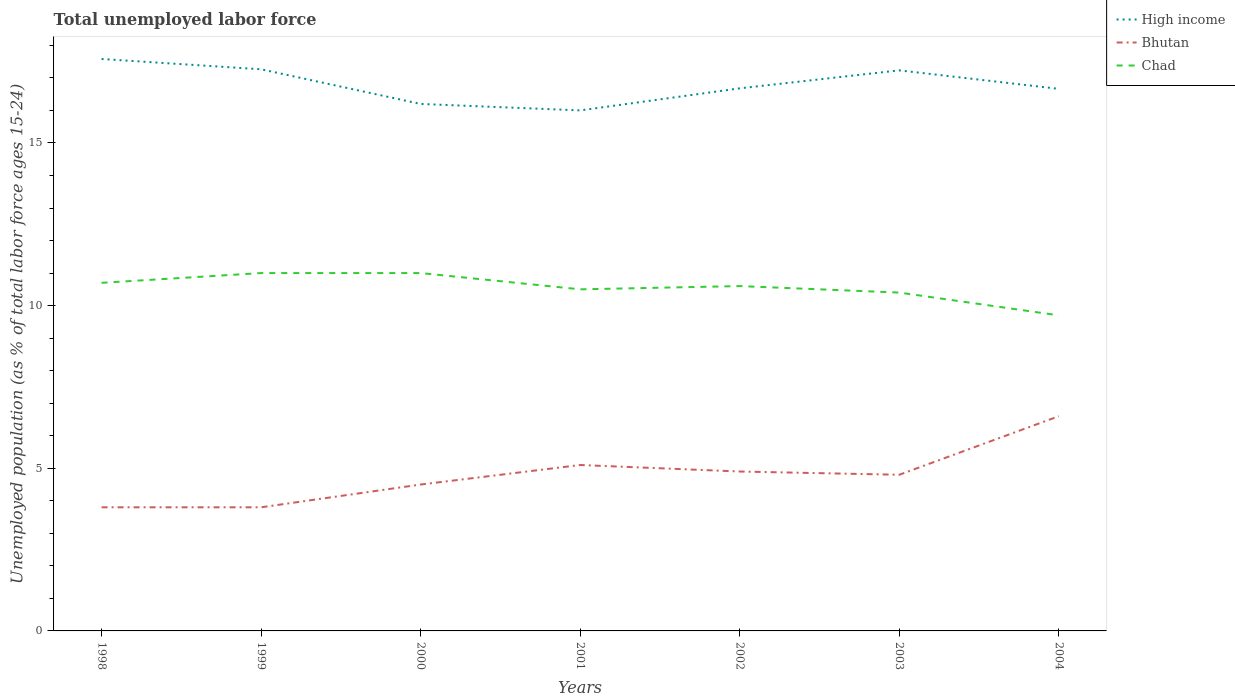Is the number of lines equal to the number of legend labels?
Give a very brief answer. Yes. Across all years, what is the maximum percentage of unemployed population in in High income?
Give a very brief answer. 16. What is the total percentage of unemployed population in in Chad in the graph?
Keep it short and to the point. 1.3. What is the difference between the highest and the second highest percentage of unemployed population in in Bhutan?
Provide a succinct answer. 2.8. What is the difference between the highest and the lowest percentage of unemployed population in in Chad?
Give a very brief answer. 4. Is the percentage of unemployed population in in High income strictly greater than the percentage of unemployed population in in Chad over the years?
Offer a very short reply. No. Where does the legend appear in the graph?
Provide a short and direct response. Top right. How are the legend labels stacked?
Offer a terse response. Vertical. What is the title of the graph?
Offer a terse response. Total unemployed labor force. What is the label or title of the Y-axis?
Make the answer very short. Unemployed population (as % of total labor force ages 15-24). What is the Unemployed population (as % of total labor force ages 15-24) of High income in 1998?
Offer a very short reply. 17.58. What is the Unemployed population (as % of total labor force ages 15-24) of Bhutan in 1998?
Give a very brief answer. 3.8. What is the Unemployed population (as % of total labor force ages 15-24) in Chad in 1998?
Provide a succinct answer. 10.7. What is the Unemployed population (as % of total labor force ages 15-24) of High income in 1999?
Give a very brief answer. 17.26. What is the Unemployed population (as % of total labor force ages 15-24) of Bhutan in 1999?
Make the answer very short. 3.8. What is the Unemployed population (as % of total labor force ages 15-24) in Chad in 1999?
Offer a very short reply. 11. What is the Unemployed population (as % of total labor force ages 15-24) in High income in 2000?
Your response must be concise. 16.2. What is the Unemployed population (as % of total labor force ages 15-24) of Chad in 2000?
Your answer should be very brief. 11. What is the Unemployed population (as % of total labor force ages 15-24) of High income in 2001?
Offer a very short reply. 16. What is the Unemployed population (as % of total labor force ages 15-24) of Bhutan in 2001?
Make the answer very short. 5.1. What is the Unemployed population (as % of total labor force ages 15-24) of Chad in 2001?
Your answer should be compact. 10.5. What is the Unemployed population (as % of total labor force ages 15-24) of High income in 2002?
Give a very brief answer. 16.68. What is the Unemployed population (as % of total labor force ages 15-24) of Bhutan in 2002?
Make the answer very short. 4.9. What is the Unemployed population (as % of total labor force ages 15-24) of Chad in 2002?
Your response must be concise. 10.6. What is the Unemployed population (as % of total labor force ages 15-24) in High income in 2003?
Ensure brevity in your answer.  17.23. What is the Unemployed population (as % of total labor force ages 15-24) of Bhutan in 2003?
Your answer should be compact. 4.8. What is the Unemployed population (as % of total labor force ages 15-24) of Chad in 2003?
Provide a succinct answer. 10.4. What is the Unemployed population (as % of total labor force ages 15-24) in High income in 2004?
Give a very brief answer. 16.66. What is the Unemployed population (as % of total labor force ages 15-24) in Bhutan in 2004?
Your answer should be very brief. 6.6. What is the Unemployed population (as % of total labor force ages 15-24) in Chad in 2004?
Offer a terse response. 9.7. Across all years, what is the maximum Unemployed population (as % of total labor force ages 15-24) of High income?
Your response must be concise. 17.58. Across all years, what is the maximum Unemployed population (as % of total labor force ages 15-24) in Bhutan?
Ensure brevity in your answer.  6.6. Across all years, what is the minimum Unemployed population (as % of total labor force ages 15-24) in High income?
Ensure brevity in your answer.  16. Across all years, what is the minimum Unemployed population (as % of total labor force ages 15-24) of Bhutan?
Offer a very short reply. 3.8. Across all years, what is the minimum Unemployed population (as % of total labor force ages 15-24) in Chad?
Keep it short and to the point. 9.7. What is the total Unemployed population (as % of total labor force ages 15-24) of High income in the graph?
Keep it short and to the point. 117.61. What is the total Unemployed population (as % of total labor force ages 15-24) of Bhutan in the graph?
Offer a terse response. 33.5. What is the total Unemployed population (as % of total labor force ages 15-24) in Chad in the graph?
Offer a very short reply. 73.9. What is the difference between the Unemployed population (as % of total labor force ages 15-24) of High income in 1998 and that in 1999?
Give a very brief answer. 0.32. What is the difference between the Unemployed population (as % of total labor force ages 15-24) in Bhutan in 1998 and that in 1999?
Your answer should be compact. 0. What is the difference between the Unemployed population (as % of total labor force ages 15-24) in High income in 1998 and that in 2000?
Give a very brief answer. 1.38. What is the difference between the Unemployed population (as % of total labor force ages 15-24) in Bhutan in 1998 and that in 2000?
Your answer should be very brief. -0.7. What is the difference between the Unemployed population (as % of total labor force ages 15-24) of High income in 1998 and that in 2001?
Offer a terse response. 1.58. What is the difference between the Unemployed population (as % of total labor force ages 15-24) in Chad in 1998 and that in 2001?
Provide a short and direct response. 0.2. What is the difference between the Unemployed population (as % of total labor force ages 15-24) in High income in 1998 and that in 2002?
Your answer should be compact. 0.9. What is the difference between the Unemployed population (as % of total labor force ages 15-24) of High income in 1998 and that in 2003?
Your answer should be compact. 0.35. What is the difference between the Unemployed population (as % of total labor force ages 15-24) in Bhutan in 1998 and that in 2003?
Offer a terse response. -1. What is the difference between the Unemployed population (as % of total labor force ages 15-24) in Chad in 1998 and that in 2003?
Offer a very short reply. 0.3. What is the difference between the Unemployed population (as % of total labor force ages 15-24) of High income in 1998 and that in 2004?
Offer a terse response. 0.92. What is the difference between the Unemployed population (as % of total labor force ages 15-24) in Bhutan in 1998 and that in 2004?
Offer a terse response. -2.8. What is the difference between the Unemployed population (as % of total labor force ages 15-24) of High income in 1999 and that in 2000?
Your response must be concise. 1.06. What is the difference between the Unemployed population (as % of total labor force ages 15-24) in Bhutan in 1999 and that in 2000?
Your answer should be compact. -0.7. What is the difference between the Unemployed population (as % of total labor force ages 15-24) in High income in 1999 and that in 2001?
Your answer should be compact. 1.26. What is the difference between the Unemployed population (as % of total labor force ages 15-24) of High income in 1999 and that in 2002?
Your response must be concise. 0.59. What is the difference between the Unemployed population (as % of total labor force ages 15-24) of High income in 1999 and that in 2003?
Make the answer very short. 0.03. What is the difference between the Unemployed population (as % of total labor force ages 15-24) of Bhutan in 1999 and that in 2003?
Offer a very short reply. -1. What is the difference between the Unemployed population (as % of total labor force ages 15-24) in High income in 1999 and that in 2004?
Keep it short and to the point. 0.6. What is the difference between the Unemployed population (as % of total labor force ages 15-24) in High income in 2000 and that in 2001?
Your answer should be compact. 0.2. What is the difference between the Unemployed population (as % of total labor force ages 15-24) of Chad in 2000 and that in 2001?
Your answer should be very brief. 0.5. What is the difference between the Unemployed population (as % of total labor force ages 15-24) of High income in 2000 and that in 2002?
Provide a short and direct response. -0.48. What is the difference between the Unemployed population (as % of total labor force ages 15-24) in Bhutan in 2000 and that in 2002?
Offer a very short reply. -0.4. What is the difference between the Unemployed population (as % of total labor force ages 15-24) in High income in 2000 and that in 2003?
Your answer should be very brief. -1.03. What is the difference between the Unemployed population (as % of total labor force ages 15-24) of High income in 2000 and that in 2004?
Your answer should be compact. -0.46. What is the difference between the Unemployed population (as % of total labor force ages 15-24) in Bhutan in 2000 and that in 2004?
Keep it short and to the point. -2.1. What is the difference between the Unemployed population (as % of total labor force ages 15-24) in High income in 2001 and that in 2002?
Offer a very short reply. -0.68. What is the difference between the Unemployed population (as % of total labor force ages 15-24) of Bhutan in 2001 and that in 2002?
Make the answer very short. 0.2. What is the difference between the Unemployed population (as % of total labor force ages 15-24) in High income in 2001 and that in 2003?
Your response must be concise. -1.23. What is the difference between the Unemployed population (as % of total labor force ages 15-24) in Bhutan in 2001 and that in 2003?
Make the answer very short. 0.3. What is the difference between the Unemployed population (as % of total labor force ages 15-24) of High income in 2001 and that in 2004?
Offer a terse response. -0.66. What is the difference between the Unemployed population (as % of total labor force ages 15-24) in Bhutan in 2001 and that in 2004?
Give a very brief answer. -1.5. What is the difference between the Unemployed population (as % of total labor force ages 15-24) in Chad in 2001 and that in 2004?
Your response must be concise. 0.8. What is the difference between the Unemployed population (as % of total labor force ages 15-24) in High income in 2002 and that in 2003?
Your answer should be compact. -0.55. What is the difference between the Unemployed population (as % of total labor force ages 15-24) in Chad in 2002 and that in 2003?
Offer a very short reply. 0.2. What is the difference between the Unemployed population (as % of total labor force ages 15-24) of High income in 2002 and that in 2004?
Provide a short and direct response. 0.02. What is the difference between the Unemployed population (as % of total labor force ages 15-24) of High income in 2003 and that in 2004?
Keep it short and to the point. 0.57. What is the difference between the Unemployed population (as % of total labor force ages 15-24) of Bhutan in 2003 and that in 2004?
Your answer should be very brief. -1.8. What is the difference between the Unemployed population (as % of total labor force ages 15-24) of High income in 1998 and the Unemployed population (as % of total labor force ages 15-24) of Bhutan in 1999?
Keep it short and to the point. 13.78. What is the difference between the Unemployed population (as % of total labor force ages 15-24) in High income in 1998 and the Unemployed population (as % of total labor force ages 15-24) in Chad in 1999?
Make the answer very short. 6.58. What is the difference between the Unemployed population (as % of total labor force ages 15-24) of Bhutan in 1998 and the Unemployed population (as % of total labor force ages 15-24) of Chad in 1999?
Keep it short and to the point. -7.2. What is the difference between the Unemployed population (as % of total labor force ages 15-24) of High income in 1998 and the Unemployed population (as % of total labor force ages 15-24) of Bhutan in 2000?
Keep it short and to the point. 13.08. What is the difference between the Unemployed population (as % of total labor force ages 15-24) of High income in 1998 and the Unemployed population (as % of total labor force ages 15-24) of Chad in 2000?
Ensure brevity in your answer.  6.58. What is the difference between the Unemployed population (as % of total labor force ages 15-24) of Bhutan in 1998 and the Unemployed population (as % of total labor force ages 15-24) of Chad in 2000?
Your answer should be compact. -7.2. What is the difference between the Unemployed population (as % of total labor force ages 15-24) of High income in 1998 and the Unemployed population (as % of total labor force ages 15-24) of Bhutan in 2001?
Make the answer very short. 12.48. What is the difference between the Unemployed population (as % of total labor force ages 15-24) of High income in 1998 and the Unemployed population (as % of total labor force ages 15-24) of Chad in 2001?
Your response must be concise. 7.08. What is the difference between the Unemployed population (as % of total labor force ages 15-24) of High income in 1998 and the Unemployed population (as % of total labor force ages 15-24) of Bhutan in 2002?
Your response must be concise. 12.68. What is the difference between the Unemployed population (as % of total labor force ages 15-24) in High income in 1998 and the Unemployed population (as % of total labor force ages 15-24) in Chad in 2002?
Offer a very short reply. 6.98. What is the difference between the Unemployed population (as % of total labor force ages 15-24) of High income in 1998 and the Unemployed population (as % of total labor force ages 15-24) of Bhutan in 2003?
Give a very brief answer. 12.78. What is the difference between the Unemployed population (as % of total labor force ages 15-24) in High income in 1998 and the Unemployed population (as % of total labor force ages 15-24) in Chad in 2003?
Your answer should be very brief. 7.18. What is the difference between the Unemployed population (as % of total labor force ages 15-24) in Bhutan in 1998 and the Unemployed population (as % of total labor force ages 15-24) in Chad in 2003?
Your response must be concise. -6.6. What is the difference between the Unemployed population (as % of total labor force ages 15-24) of High income in 1998 and the Unemployed population (as % of total labor force ages 15-24) of Bhutan in 2004?
Your response must be concise. 10.98. What is the difference between the Unemployed population (as % of total labor force ages 15-24) of High income in 1998 and the Unemployed population (as % of total labor force ages 15-24) of Chad in 2004?
Give a very brief answer. 7.88. What is the difference between the Unemployed population (as % of total labor force ages 15-24) in Bhutan in 1998 and the Unemployed population (as % of total labor force ages 15-24) in Chad in 2004?
Offer a very short reply. -5.9. What is the difference between the Unemployed population (as % of total labor force ages 15-24) in High income in 1999 and the Unemployed population (as % of total labor force ages 15-24) in Bhutan in 2000?
Offer a terse response. 12.76. What is the difference between the Unemployed population (as % of total labor force ages 15-24) in High income in 1999 and the Unemployed population (as % of total labor force ages 15-24) in Chad in 2000?
Ensure brevity in your answer.  6.26. What is the difference between the Unemployed population (as % of total labor force ages 15-24) of Bhutan in 1999 and the Unemployed population (as % of total labor force ages 15-24) of Chad in 2000?
Keep it short and to the point. -7.2. What is the difference between the Unemployed population (as % of total labor force ages 15-24) of High income in 1999 and the Unemployed population (as % of total labor force ages 15-24) of Bhutan in 2001?
Your response must be concise. 12.16. What is the difference between the Unemployed population (as % of total labor force ages 15-24) in High income in 1999 and the Unemployed population (as % of total labor force ages 15-24) in Chad in 2001?
Offer a terse response. 6.76. What is the difference between the Unemployed population (as % of total labor force ages 15-24) in High income in 1999 and the Unemployed population (as % of total labor force ages 15-24) in Bhutan in 2002?
Ensure brevity in your answer.  12.36. What is the difference between the Unemployed population (as % of total labor force ages 15-24) of High income in 1999 and the Unemployed population (as % of total labor force ages 15-24) of Chad in 2002?
Your answer should be very brief. 6.66. What is the difference between the Unemployed population (as % of total labor force ages 15-24) in Bhutan in 1999 and the Unemployed population (as % of total labor force ages 15-24) in Chad in 2002?
Your response must be concise. -6.8. What is the difference between the Unemployed population (as % of total labor force ages 15-24) in High income in 1999 and the Unemployed population (as % of total labor force ages 15-24) in Bhutan in 2003?
Your answer should be compact. 12.46. What is the difference between the Unemployed population (as % of total labor force ages 15-24) of High income in 1999 and the Unemployed population (as % of total labor force ages 15-24) of Chad in 2003?
Make the answer very short. 6.86. What is the difference between the Unemployed population (as % of total labor force ages 15-24) in Bhutan in 1999 and the Unemployed population (as % of total labor force ages 15-24) in Chad in 2003?
Offer a very short reply. -6.6. What is the difference between the Unemployed population (as % of total labor force ages 15-24) in High income in 1999 and the Unemployed population (as % of total labor force ages 15-24) in Bhutan in 2004?
Your answer should be compact. 10.66. What is the difference between the Unemployed population (as % of total labor force ages 15-24) in High income in 1999 and the Unemployed population (as % of total labor force ages 15-24) in Chad in 2004?
Make the answer very short. 7.56. What is the difference between the Unemployed population (as % of total labor force ages 15-24) of Bhutan in 1999 and the Unemployed population (as % of total labor force ages 15-24) of Chad in 2004?
Provide a succinct answer. -5.9. What is the difference between the Unemployed population (as % of total labor force ages 15-24) of High income in 2000 and the Unemployed population (as % of total labor force ages 15-24) of Bhutan in 2001?
Provide a short and direct response. 11.1. What is the difference between the Unemployed population (as % of total labor force ages 15-24) in High income in 2000 and the Unemployed population (as % of total labor force ages 15-24) in Chad in 2001?
Provide a short and direct response. 5.7. What is the difference between the Unemployed population (as % of total labor force ages 15-24) of Bhutan in 2000 and the Unemployed population (as % of total labor force ages 15-24) of Chad in 2001?
Ensure brevity in your answer.  -6. What is the difference between the Unemployed population (as % of total labor force ages 15-24) of High income in 2000 and the Unemployed population (as % of total labor force ages 15-24) of Bhutan in 2002?
Ensure brevity in your answer.  11.3. What is the difference between the Unemployed population (as % of total labor force ages 15-24) in High income in 2000 and the Unemployed population (as % of total labor force ages 15-24) in Chad in 2002?
Offer a very short reply. 5.6. What is the difference between the Unemployed population (as % of total labor force ages 15-24) of Bhutan in 2000 and the Unemployed population (as % of total labor force ages 15-24) of Chad in 2002?
Offer a terse response. -6.1. What is the difference between the Unemployed population (as % of total labor force ages 15-24) of High income in 2000 and the Unemployed population (as % of total labor force ages 15-24) of Bhutan in 2003?
Keep it short and to the point. 11.4. What is the difference between the Unemployed population (as % of total labor force ages 15-24) in High income in 2000 and the Unemployed population (as % of total labor force ages 15-24) in Chad in 2003?
Give a very brief answer. 5.8. What is the difference between the Unemployed population (as % of total labor force ages 15-24) of Bhutan in 2000 and the Unemployed population (as % of total labor force ages 15-24) of Chad in 2003?
Keep it short and to the point. -5.9. What is the difference between the Unemployed population (as % of total labor force ages 15-24) in High income in 2000 and the Unemployed population (as % of total labor force ages 15-24) in Bhutan in 2004?
Your response must be concise. 9.6. What is the difference between the Unemployed population (as % of total labor force ages 15-24) in High income in 2000 and the Unemployed population (as % of total labor force ages 15-24) in Chad in 2004?
Your answer should be compact. 6.5. What is the difference between the Unemployed population (as % of total labor force ages 15-24) in High income in 2001 and the Unemployed population (as % of total labor force ages 15-24) in Bhutan in 2002?
Provide a short and direct response. 11.1. What is the difference between the Unemployed population (as % of total labor force ages 15-24) in High income in 2001 and the Unemployed population (as % of total labor force ages 15-24) in Chad in 2002?
Keep it short and to the point. 5.4. What is the difference between the Unemployed population (as % of total labor force ages 15-24) in Bhutan in 2001 and the Unemployed population (as % of total labor force ages 15-24) in Chad in 2002?
Your answer should be very brief. -5.5. What is the difference between the Unemployed population (as % of total labor force ages 15-24) of High income in 2001 and the Unemployed population (as % of total labor force ages 15-24) of Bhutan in 2003?
Offer a very short reply. 11.2. What is the difference between the Unemployed population (as % of total labor force ages 15-24) of High income in 2001 and the Unemployed population (as % of total labor force ages 15-24) of Chad in 2003?
Your answer should be compact. 5.6. What is the difference between the Unemployed population (as % of total labor force ages 15-24) in Bhutan in 2001 and the Unemployed population (as % of total labor force ages 15-24) in Chad in 2003?
Offer a terse response. -5.3. What is the difference between the Unemployed population (as % of total labor force ages 15-24) of High income in 2001 and the Unemployed population (as % of total labor force ages 15-24) of Bhutan in 2004?
Offer a terse response. 9.4. What is the difference between the Unemployed population (as % of total labor force ages 15-24) in High income in 2001 and the Unemployed population (as % of total labor force ages 15-24) in Chad in 2004?
Your answer should be very brief. 6.3. What is the difference between the Unemployed population (as % of total labor force ages 15-24) in Bhutan in 2001 and the Unemployed population (as % of total labor force ages 15-24) in Chad in 2004?
Provide a short and direct response. -4.6. What is the difference between the Unemployed population (as % of total labor force ages 15-24) of High income in 2002 and the Unemployed population (as % of total labor force ages 15-24) of Bhutan in 2003?
Your response must be concise. 11.88. What is the difference between the Unemployed population (as % of total labor force ages 15-24) of High income in 2002 and the Unemployed population (as % of total labor force ages 15-24) of Chad in 2003?
Make the answer very short. 6.28. What is the difference between the Unemployed population (as % of total labor force ages 15-24) in High income in 2002 and the Unemployed population (as % of total labor force ages 15-24) in Bhutan in 2004?
Give a very brief answer. 10.08. What is the difference between the Unemployed population (as % of total labor force ages 15-24) of High income in 2002 and the Unemployed population (as % of total labor force ages 15-24) of Chad in 2004?
Make the answer very short. 6.98. What is the difference between the Unemployed population (as % of total labor force ages 15-24) of High income in 2003 and the Unemployed population (as % of total labor force ages 15-24) of Bhutan in 2004?
Provide a short and direct response. 10.63. What is the difference between the Unemployed population (as % of total labor force ages 15-24) in High income in 2003 and the Unemployed population (as % of total labor force ages 15-24) in Chad in 2004?
Offer a very short reply. 7.53. What is the difference between the Unemployed population (as % of total labor force ages 15-24) in Bhutan in 2003 and the Unemployed population (as % of total labor force ages 15-24) in Chad in 2004?
Provide a short and direct response. -4.9. What is the average Unemployed population (as % of total labor force ages 15-24) of High income per year?
Provide a short and direct response. 16.8. What is the average Unemployed population (as % of total labor force ages 15-24) in Bhutan per year?
Ensure brevity in your answer.  4.79. What is the average Unemployed population (as % of total labor force ages 15-24) of Chad per year?
Your answer should be compact. 10.56. In the year 1998, what is the difference between the Unemployed population (as % of total labor force ages 15-24) in High income and Unemployed population (as % of total labor force ages 15-24) in Bhutan?
Offer a very short reply. 13.78. In the year 1998, what is the difference between the Unemployed population (as % of total labor force ages 15-24) in High income and Unemployed population (as % of total labor force ages 15-24) in Chad?
Provide a short and direct response. 6.88. In the year 1999, what is the difference between the Unemployed population (as % of total labor force ages 15-24) in High income and Unemployed population (as % of total labor force ages 15-24) in Bhutan?
Offer a very short reply. 13.46. In the year 1999, what is the difference between the Unemployed population (as % of total labor force ages 15-24) in High income and Unemployed population (as % of total labor force ages 15-24) in Chad?
Provide a short and direct response. 6.26. In the year 1999, what is the difference between the Unemployed population (as % of total labor force ages 15-24) in Bhutan and Unemployed population (as % of total labor force ages 15-24) in Chad?
Provide a succinct answer. -7.2. In the year 2000, what is the difference between the Unemployed population (as % of total labor force ages 15-24) of High income and Unemployed population (as % of total labor force ages 15-24) of Bhutan?
Offer a terse response. 11.7. In the year 2000, what is the difference between the Unemployed population (as % of total labor force ages 15-24) in High income and Unemployed population (as % of total labor force ages 15-24) in Chad?
Provide a succinct answer. 5.2. In the year 2001, what is the difference between the Unemployed population (as % of total labor force ages 15-24) in High income and Unemployed population (as % of total labor force ages 15-24) in Bhutan?
Ensure brevity in your answer.  10.9. In the year 2001, what is the difference between the Unemployed population (as % of total labor force ages 15-24) of High income and Unemployed population (as % of total labor force ages 15-24) of Chad?
Offer a terse response. 5.5. In the year 2002, what is the difference between the Unemployed population (as % of total labor force ages 15-24) in High income and Unemployed population (as % of total labor force ages 15-24) in Bhutan?
Make the answer very short. 11.78. In the year 2002, what is the difference between the Unemployed population (as % of total labor force ages 15-24) in High income and Unemployed population (as % of total labor force ages 15-24) in Chad?
Make the answer very short. 6.08. In the year 2003, what is the difference between the Unemployed population (as % of total labor force ages 15-24) of High income and Unemployed population (as % of total labor force ages 15-24) of Bhutan?
Your response must be concise. 12.43. In the year 2003, what is the difference between the Unemployed population (as % of total labor force ages 15-24) of High income and Unemployed population (as % of total labor force ages 15-24) of Chad?
Ensure brevity in your answer.  6.83. In the year 2004, what is the difference between the Unemployed population (as % of total labor force ages 15-24) in High income and Unemployed population (as % of total labor force ages 15-24) in Bhutan?
Your answer should be very brief. 10.06. In the year 2004, what is the difference between the Unemployed population (as % of total labor force ages 15-24) of High income and Unemployed population (as % of total labor force ages 15-24) of Chad?
Make the answer very short. 6.96. In the year 2004, what is the difference between the Unemployed population (as % of total labor force ages 15-24) in Bhutan and Unemployed population (as % of total labor force ages 15-24) in Chad?
Provide a succinct answer. -3.1. What is the ratio of the Unemployed population (as % of total labor force ages 15-24) of High income in 1998 to that in 1999?
Offer a terse response. 1.02. What is the ratio of the Unemployed population (as % of total labor force ages 15-24) in Bhutan in 1998 to that in 1999?
Make the answer very short. 1. What is the ratio of the Unemployed population (as % of total labor force ages 15-24) in Chad in 1998 to that in 1999?
Give a very brief answer. 0.97. What is the ratio of the Unemployed population (as % of total labor force ages 15-24) of High income in 1998 to that in 2000?
Provide a short and direct response. 1.09. What is the ratio of the Unemployed population (as % of total labor force ages 15-24) in Bhutan in 1998 to that in 2000?
Make the answer very short. 0.84. What is the ratio of the Unemployed population (as % of total labor force ages 15-24) of Chad in 1998 to that in 2000?
Keep it short and to the point. 0.97. What is the ratio of the Unemployed population (as % of total labor force ages 15-24) in High income in 1998 to that in 2001?
Provide a succinct answer. 1.1. What is the ratio of the Unemployed population (as % of total labor force ages 15-24) in Bhutan in 1998 to that in 2001?
Offer a terse response. 0.75. What is the ratio of the Unemployed population (as % of total labor force ages 15-24) in High income in 1998 to that in 2002?
Offer a very short reply. 1.05. What is the ratio of the Unemployed population (as % of total labor force ages 15-24) in Bhutan in 1998 to that in 2002?
Ensure brevity in your answer.  0.78. What is the ratio of the Unemployed population (as % of total labor force ages 15-24) in Chad in 1998 to that in 2002?
Your response must be concise. 1.01. What is the ratio of the Unemployed population (as % of total labor force ages 15-24) in High income in 1998 to that in 2003?
Offer a terse response. 1.02. What is the ratio of the Unemployed population (as % of total labor force ages 15-24) in Bhutan in 1998 to that in 2003?
Make the answer very short. 0.79. What is the ratio of the Unemployed population (as % of total labor force ages 15-24) in Chad in 1998 to that in 2003?
Offer a terse response. 1.03. What is the ratio of the Unemployed population (as % of total labor force ages 15-24) in High income in 1998 to that in 2004?
Your answer should be compact. 1.06. What is the ratio of the Unemployed population (as % of total labor force ages 15-24) in Bhutan in 1998 to that in 2004?
Provide a short and direct response. 0.58. What is the ratio of the Unemployed population (as % of total labor force ages 15-24) of Chad in 1998 to that in 2004?
Give a very brief answer. 1.1. What is the ratio of the Unemployed population (as % of total labor force ages 15-24) in High income in 1999 to that in 2000?
Ensure brevity in your answer.  1.07. What is the ratio of the Unemployed population (as % of total labor force ages 15-24) in Bhutan in 1999 to that in 2000?
Ensure brevity in your answer.  0.84. What is the ratio of the Unemployed population (as % of total labor force ages 15-24) of Chad in 1999 to that in 2000?
Your answer should be compact. 1. What is the ratio of the Unemployed population (as % of total labor force ages 15-24) of High income in 1999 to that in 2001?
Offer a terse response. 1.08. What is the ratio of the Unemployed population (as % of total labor force ages 15-24) of Bhutan in 1999 to that in 2001?
Offer a terse response. 0.75. What is the ratio of the Unemployed population (as % of total labor force ages 15-24) in Chad in 1999 to that in 2001?
Your response must be concise. 1.05. What is the ratio of the Unemployed population (as % of total labor force ages 15-24) of High income in 1999 to that in 2002?
Your response must be concise. 1.04. What is the ratio of the Unemployed population (as % of total labor force ages 15-24) of Bhutan in 1999 to that in 2002?
Make the answer very short. 0.78. What is the ratio of the Unemployed population (as % of total labor force ages 15-24) in Chad in 1999 to that in 2002?
Ensure brevity in your answer.  1.04. What is the ratio of the Unemployed population (as % of total labor force ages 15-24) in Bhutan in 1999 to that in 2003?
Make the answer very short. 0.79. What is the ratio of the Unemployed population (as % of total labor force ages 15-24) in Chad in 1999 to that in 2003?
Give a very brief answer. 1.06. What is the ratio of the Unemployed population (as % of total labor force ages 15-24) of High income in 1999 to that in 2004?
Your answer should be very brief. 1.04. What is the ratio of the Unemployed population (as % of total labor force ages 15-24) of Bhutan in 1999 to that in 2004?
Keep it short and to the point. 0.58. What is the ratio of the Unemployed population (as % of total labor force ages 15-24) in Chad in 1999 to that in 2004?
Give a very brief answer. 1.13. What is the ratio of the Unemployed population (as % of total labor force ages 15-24) in High income in 2000 to that in 2001?
Give a very brief answer. 1.01. What is the ratio of the Unemployed population (as % of total labor force ages 15-24) in Bhutan in 2000 to that in 2001?
Ensure brevity in your answer.  0.88. What is the ratio of the Unemployed population (as % of total labor force ages 15-24) in Chad in 2000 to that in 2001?
Offer a very short reply. 1.05. What is the ratio of the Unemployed population (as % of total labor force ages 15-24) of High income in 2000 to that in 2002?
Give a very brief answer. 0.97. What is the ratio of the Unemployed population (as % of total labor force ages 15-24) of Bhutan in 2000 to that in 2002?
Your answer should be very brief. 0.92. What is the ratio of the Unemployed population (as % of total labor force ages 15-24) of Chad in 2000 to that in 2002?
Provide a succinct answer. 1.04. What is the ratio of the Unemployed population (as % of total labor force ages 15-24) in High income in 2000 to that in 2003?
Make the answer very short. 0.94. What is the ratio of the Unemployed population (as % of total labor force ages 15-24) in Bhutan in 2000 to that in 2003?
Your answer should be very brief. 0.94. What is the ratio of the Unemployed population (as % of total labor force ages 15-24) in Chad in 2000 to that in 2003?
Offer a very short reply. 1.06. What is the ratio of the Unemployed population (as % of total labor force ages 15-24) in High income in 2000 to that in 2004?
Offer a very short reply. 0.97. What is the ratio of the Unemployed population (as % of total labor force ages 15-24) in Bhutan in 2000 to that in 2004?
Your answer should be very brief. 0.68. What is the ratio of the Unemployed population (as % of total labor force ages 15-24) of Chad in 2000 to that in 2004?
Keep it short and to the point. 1.13. What is the ratio of the Unemployed population (as % of total labor force ages 15-24) of High income in 2001 to that in 2002?
Your answer should be very brief. 0.96. What is the ratio of the Unemployed population (as % of total labor force ages 15-24) in Bhutan in 2001 to that in 2002?
Provide a succinct answer. 1.04. What is the ratio of the Unemployed population (as % of total labor force ages 15-24) of Chad in 2001 to that in 2002?
Your answer should be compact. 0.99. What is the ratio of the Unemployed population (as % of total labor force ages 15-24) of High income in 2001 to that in 2003?
Provide a succinct answer. 0.93. What is the ratio of the Unemployed population (as % of total labor force ages 15-24) of Bhutan in 2001 to that in 2003?
Your answer should be very brief. 1.06. What is the ratio of the Unemployed population (as % of total labor force ages 15-24) in Chad in 2001 to that in 2003?
Offer a very short reply. 1.01. What is the ratio of the Unemployed population (as % of total labor force ages 15-24) of High income in 2001 to that in 2004?
Your answer should be compact. 0.96. What is the ratio of the Unemployed population (as % of total labor force ages 15-24) of Bhutan in 2001 to that in 2004?
Make the answer very short. 0.77. What is the ratio of the Unemployed population (as % of total labor force ages 15-24) of Chad in 2001 to that in 2004?
Provide a succinct answer. 1.08. What is the ratio of the Unemployed population (as % of total labor force ages 15-24) of High income in 2002 to that in 2003?
Keep it short and to the point. 0.97. What is the ratio of the Unemployed population (as % of total labor force ages 15-24) in Bhutan in 2002 to that in 2003?
Provide a succinct answer. 1.02. What is the ratio of the Unemployed population (as % of total labor force ages 15-24) of Chad in 2002 to that in 2003?
Give a very brief answer. 1.02. What is the ratio of the Unemployed population (as % of total labor force ages 15-24) of Bhutan in 2002 to that in 2004?
Make the answer very short. 0.74. What is the ratio of the Unemployed population (as % of total labor force ages 15-24) in Chad in 2002 to that in 2004?
Provide a short and direct response. 1.09. What is the ratio of the Unemployed population (as % of total labor force ages 15-24) in High income in 2003 to that in 2004?
Make the answer very short. 1.03. What is the ratio of the Unemployed population (as % of total labor force ages 15-24) of Bhutan in 2003 to that in 2004?
Your answer should be compact. 0.73. What is the ratio of the Unemployed population (as % of total labor force ages 15-24) in Chad in 2003 to that in 2004?
Ensure brevity in your answer.  1.07. What is the difference between the highest and the second highest Unemployed population (as % of total labor force ages 15-24) in High income?
Your answer should be very brief. 0.32. What is the difference between the highest and the second highest Unemployed population (as % of total labor force ages 15-24) of Bhutan?
Give a very brief answer. 1.5. What is the difference between the highest and the second highest Unemployed population (as % of total labor force ages 15-24) of Chad?
Provide a succinct answer. 0. What is the difference between the highest and the lowest Unemployed population (as % of total labor force ages 15-24) of High income?
Give a very brief answer. 1.58. 